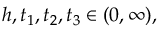<formula> <loc_0><loc_0><loc_500><loc_500>h , t _ { 1 } , t _ { 2 } , t _ { 3 } \in ( 0 , \infty ) ,</formula> 